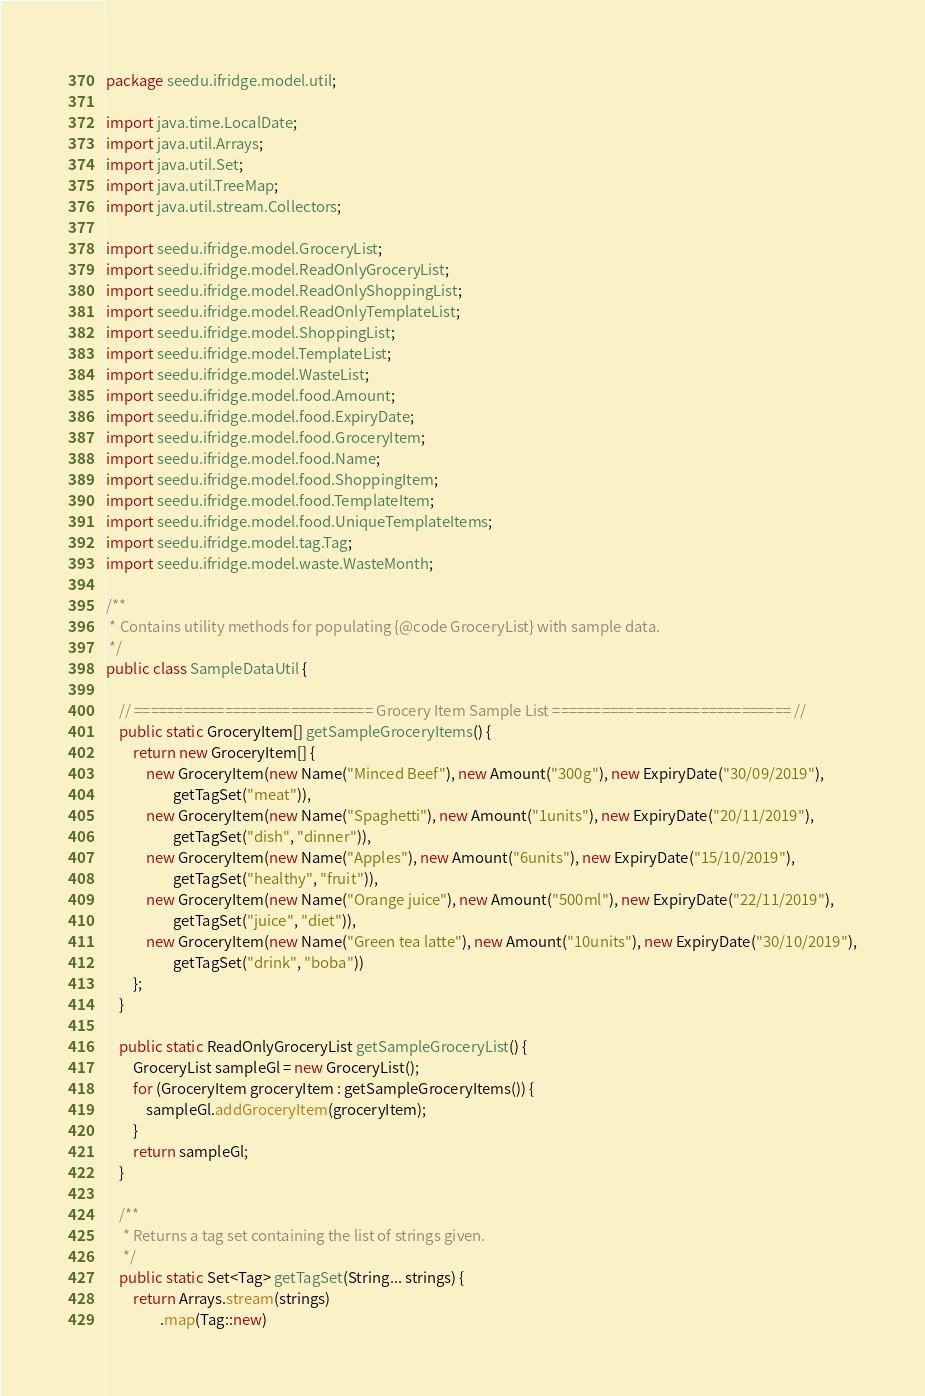Convert code to text. <code><loc_0><loc_0><loc_500><loc_500><_Java_>package seedu.ifridge.model.util;

import java.time.LocalDate;
import java.util.Arrays;
import java.util.Set;
import java.util.TreeMap;
import java.util.stream.Collectors;

import seedu.ifridge.model.GroceryList;
import seedu.ifridge.model.ReadOnlyGroceryList;
import seedu.ifridge.model.ReadOnlyShoppingList;
import seedu.ifridge.model.ReadOnlyTemplateList;
import seedu.ifridge.model.ShoppingList;
import seedu.ifridge.model.TemplateList;
import seedu.ifridge.model.WasteList;
import seedu.ifridge.model.food.Amount;
import seedu.ifridge.model.food.ExpiryDate;
import seedu.ifridge.model.food.GroceryItem;
import seedu.ifridge.model.food.Name;
import seedu.ifridge.model.food.ShoppingItem;
import seedu.ifridge.model.food.TemplateItem;
import seedu.ifridge.model.food.UniqueTemplateItems;
import seedu.ifridge.model.tag.Tag;
import seedu.ifridge.model.waste.WasteMonth;

/**
 * Contains utility methods for populating {@code GroceryList} with sample data.
 */
public class SampleDataUtil {

    // ============================= Grocery Item Sample List ============================= //
    public static GroceryItem[] getSampleGroceryItems() {
        return new GroceryItem[] {
            new GroceryItem(new Name("Minced Beef"), new Amount("300g"), new ExpiryDate("30/09/2019"),
                    getTagSet("meat")),
            new GroceryItem(new Name("Spaghetti"), new Amount("1units"), new ExpiryDate("20/11/2019"),
                    getTagSet("dish", "dinner")),
            new GroceryItem(new Name("Apples"), new Amount("6units"), new ExpiryDate("15/10/2019"),
                    getTagSet("healthy", "fruit")),
            new GroceryItem(new Name("Orange juice"), new Amount("500ml"), new ExpiryDate("22/11/2019"),
                    getTagSet("juice", "diet")),
            new GroceryItem(new Name("Green tea latte"), new Amount("10units"), new ExpiryDate("30/10/2019"),
                    getTagSet("drink", "boba"))
        };
    }

    public static ReadOnlyGroceryList getSampleGroceryList() {
        GroceryList sampleGl = new GroceryList();
        for (GroceryItem groceryItem : getSampleGroceryItems()) {
            sampleGl.addGroceryItem(groceryItem);
        }
        return sampleGl;
    }

    /**
     * Returns a tag set containing the list of strings given.
     */
    public static Set<Tag> getTagSet(String... strings) {
        return Arrays.stream(strings)
                .map(Tag::new)</code> 